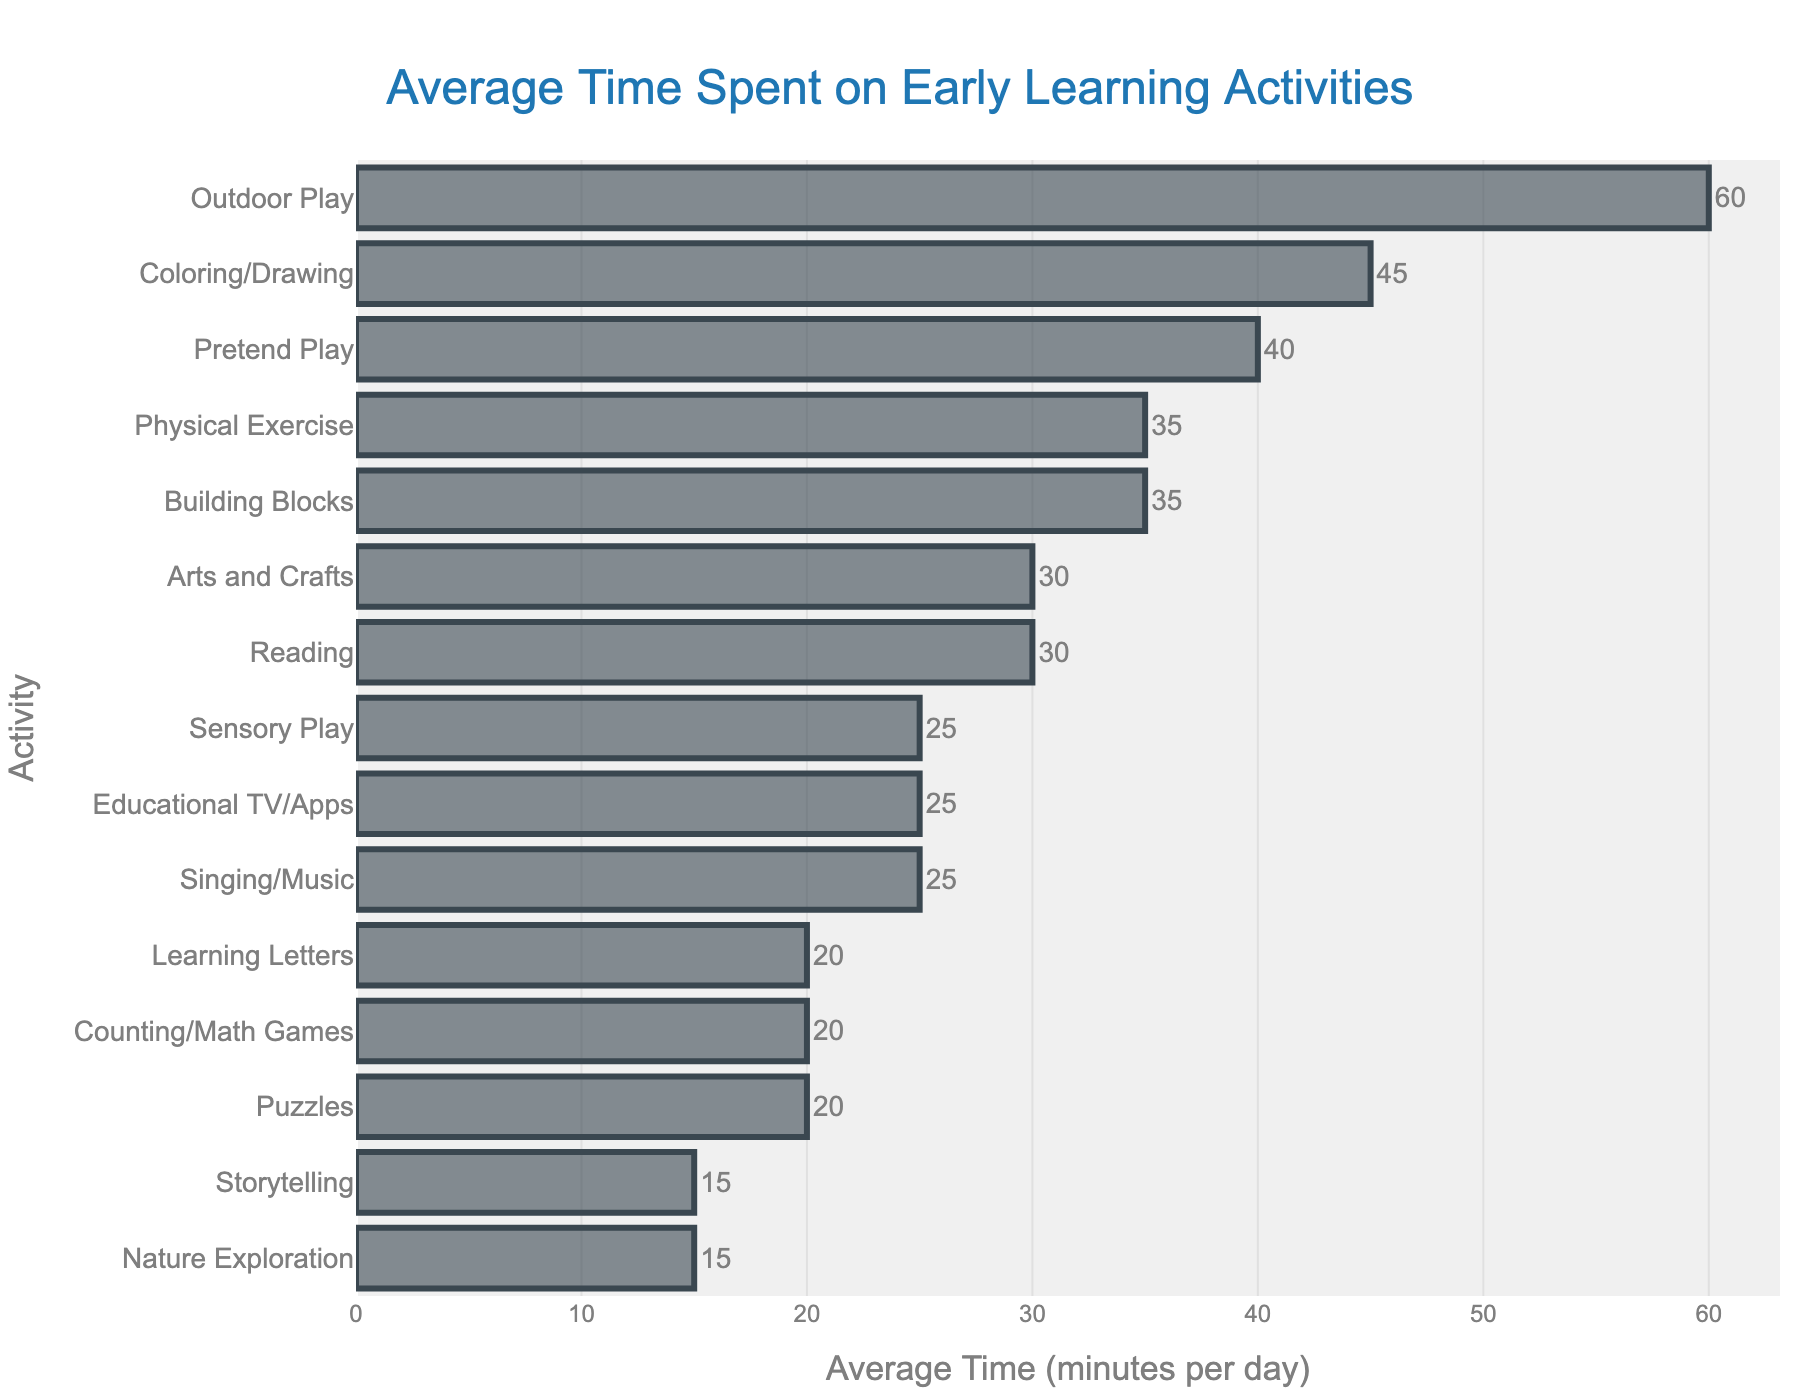Which activity has the highest average time spent? The longest bar in the bar chart represents the activity with the highest average time spent. By visually comparing the lengths of the bars, the longest one is for "Outdoor Play" which is 60 minutes per day.
Answer: Outdoor Play How much more time is spent on Coloring/Drawing compared to Puzzles? To find the difference, look at the bar lengths for Coloring/Drawing (45 minutes) and Puzzles (20 minutes) and subtract the smaller from the larger value: 45 - 20 = 25 minutes.
Answer: 25 minutes What is the median average time spent on these activities? To find the median, list the average times in ascending order: 15, 15, 20, 20, 20, 25, 25, 25, 30, 30, 35, 35, 40, 45, 60. Since there are 15 values, the median is the middle value, which is the 8th value in the ordered list: 25 minutes.
Answer: 25 minutes Which activity has the shortest average time spent? The shortest bar in the bar chart represents the activity with the least average time spent. By visually comparing the lengths of the bars, the shortest one is for "Nature Exploration" and "Storytelling," both 15 minutes per day.
Answer: Nature Exploration and Storytelling How much total time is spent on Reading, Singing/Music, and Arts and Crafts daily? Add the average times spent on Reading (30 minutes), Singing/Music (25 minutes), and Arts and Crafts (30 minutes): 30 + 25 + 30 = 85 minutes.
Answer: 85 minutes Which activities have an average time spent equal to or greater than 30 minutes per day? By looking at the bar lengths, the activities with bars reaching or exceeding 30 minutes are: Reading (30), Coloring/Drawing (45), Outdoor Play (60), Building Blocks (35), Pretend Play (40), Arts and Crafts (30), and Physical Exercise (35).
Answer: Reading, Coloring/Drawing, Outdoor Play, Building Blocks, Pretend Play, Arts and Crafts, Physical Exercise What is the average time spent per day on activities listed? Add the average times for all activities, then divide by the number of activities: (30 + 45 + 60 + 25 + 20 + 35 + 40 + 25 + 15 + 20 + 15 + 30 + 35 + 25 + 20) / 15 = 440 / 15 = 29.33 minutes per day.
Answer: 29.33 minutes How does the time spent on Pretend Play compare to Physical Exercise? Look at the bar lengths for Pretend Play (40 minutes) and Physical Exercise (35 minutes). By directly comparing these values, Pretend Play is longer by 5 minutes.
Answer: Pretend Play is 5 minutes longer 